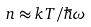Convert formula to latex. <formula><loc_0><loc_0><loc_500><loc_500>n \approx k T / \hbar { \omega }</formula> 